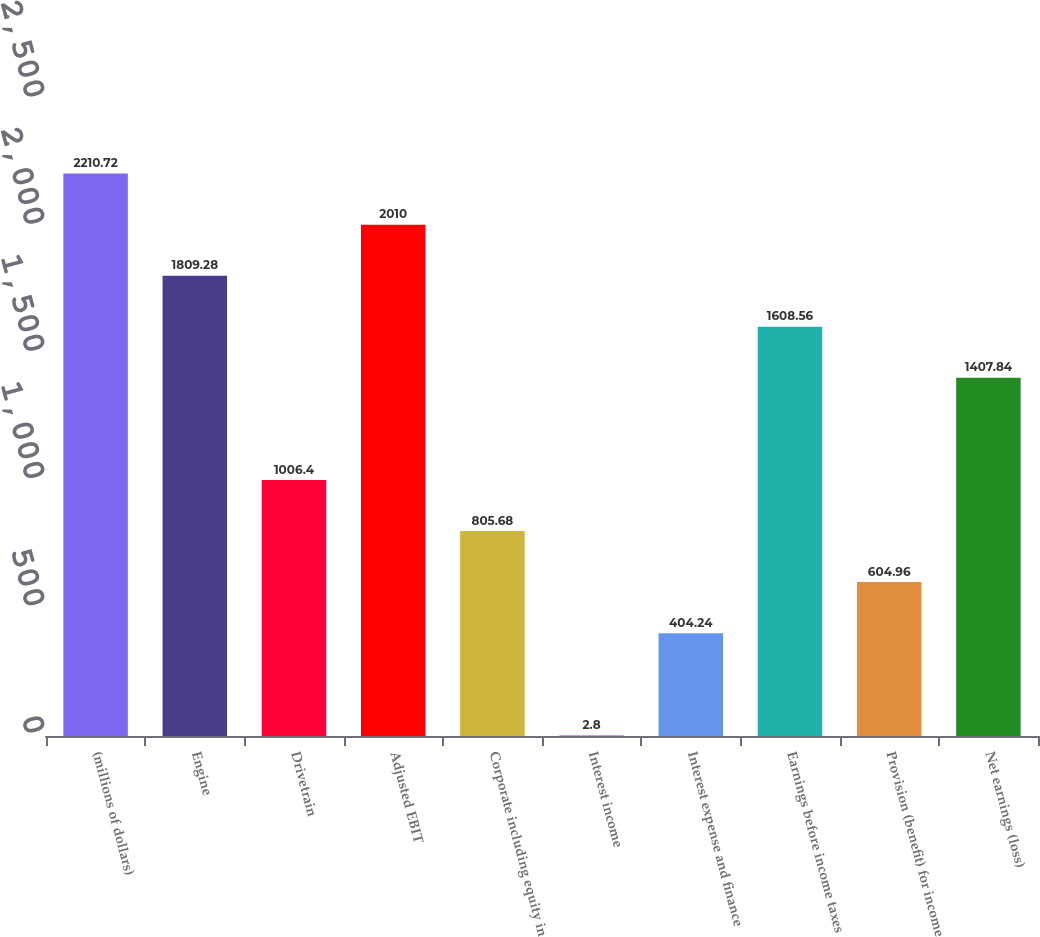Convert chart. <chart><loc_0><loc_0><loc_500><loc_500><bar_chart><fcel>(millions of dollars)<fcel>Engine<fcel>Drivetrain<fcel>Adjusted EBIT<fcel>Corporate including equity in<fcel>Interest income<fcel>Interest expense and finance<fcel>Earnings before income taxes<fcel>Provision (benefit) for income<fcel>Net earnings (loss)<nl><fcel>2210.72<fcel>1809.28<fcel>1006.4<fcel>2010<fcel>805.68<fcel>2.8<fcel>404.24<fcel>1608.56<fcel>604.96<fcel>1407.84<nl></chart> 